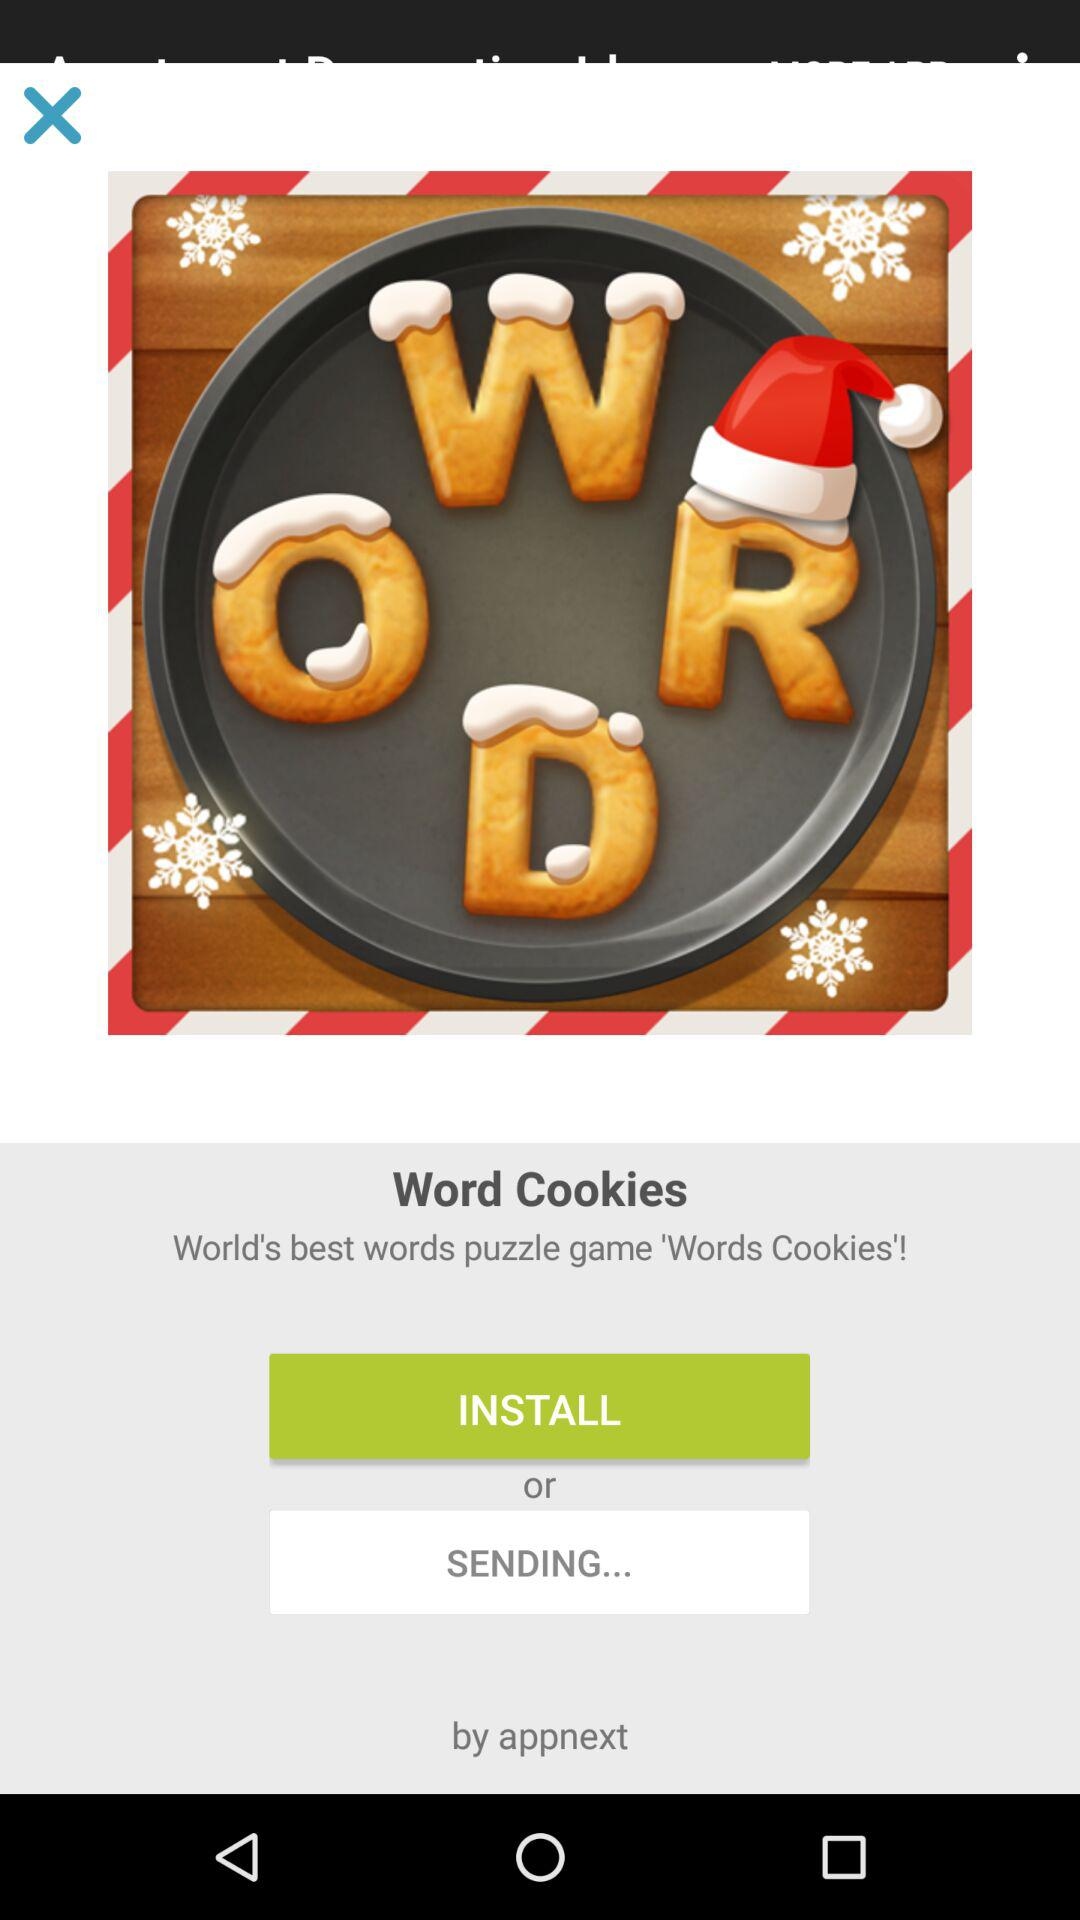How much does "Word Cookies" cost?
When the provided information is insufficient, respond with <no answer>. <no answer> 